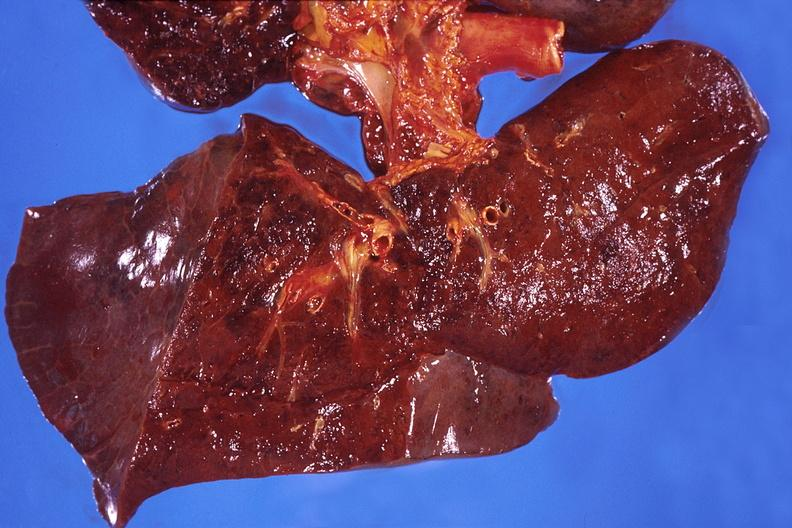where is this?
Answer the question using a single word or phrase. Lung 